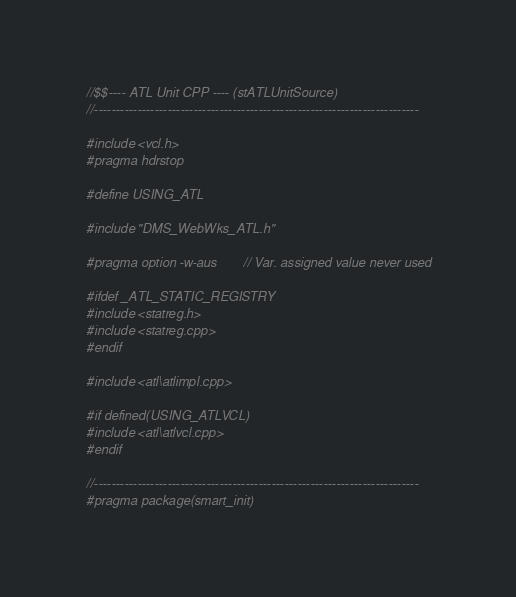<code> <loc_0><loc_0><loc_500><loc_500><_C++_>//$$---- ATL Unit CPP ---- (stATLUnitSource)
//---------------------------------------------------------------------------

#include <vcl.h>
#pragma hdrstop

#define USING_ATL

#include "DMS_WebWks_ATL.h"

#pragma option -w-aus		// Var. assigned value never used

#ifdef _ATL_STATIC_REGISTRY
#include <statreg.h>
#include <statreg.cpp>
#endif

#include <atl\atlimpl.cpp>

#if defined(USING_ATLVCL)
#include <atl\atlvcl.cpp>
#endif

//---------------------------------------------------------------------------
#pragma package(smart_init)
</code> 